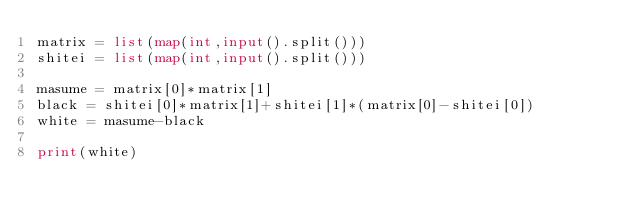<code> <loc_0><loc_0><loc_500><loc_500><_Python_>matrix = list(map(int,input().split()))
shitei = list(map(int,input().split()))

masume = matrix[0]*matrix[1]
black = shitei[0]*matrix[1]+shitei[1]*(matrix[0]-shitei[0])
white = masume-black

print(white)</code> 